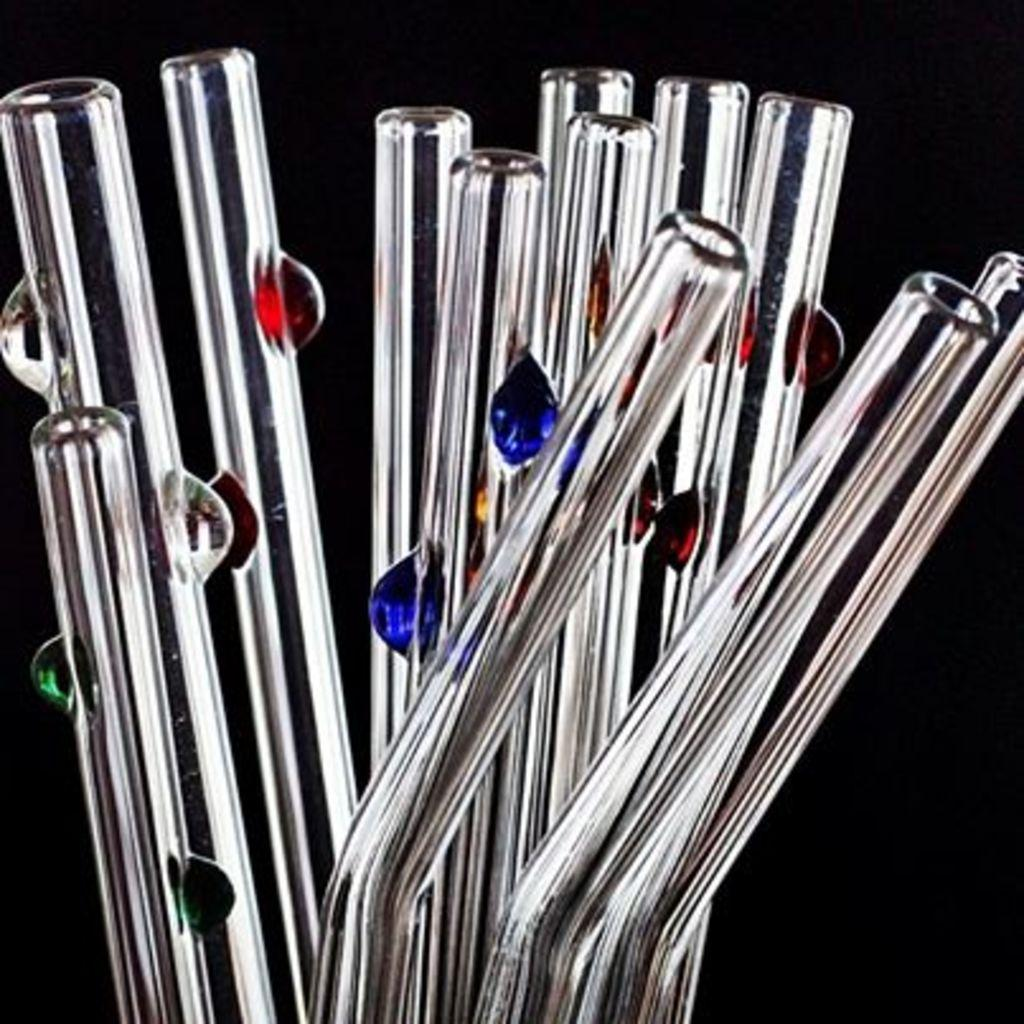What type of straws are visible in the image? There are glass straws in the image. Where can you buy these glass straws in the image? The image does not provide information about where to buy the glass straws. --- 